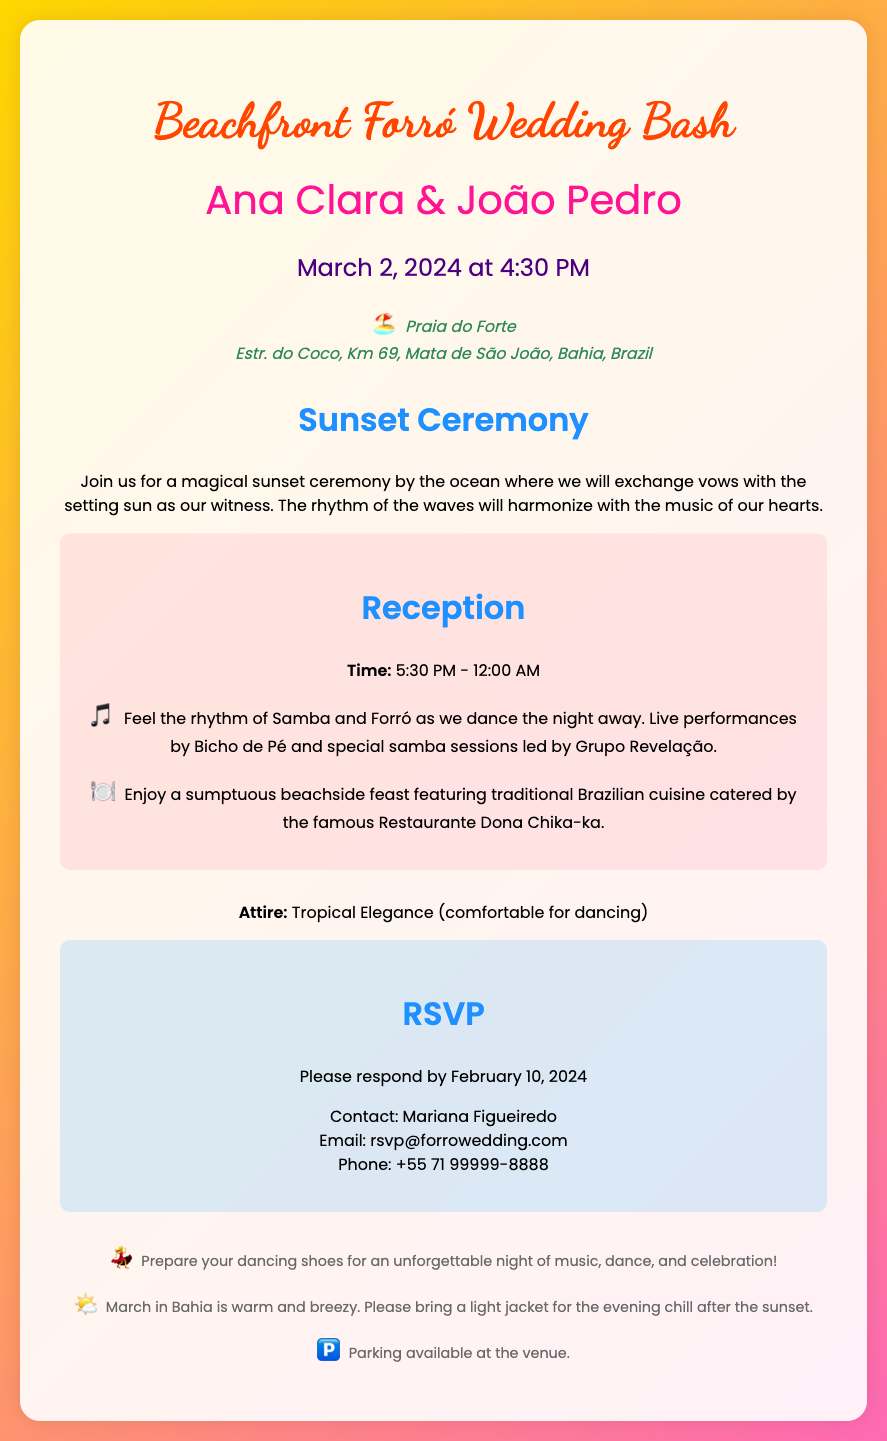What are the names of the couple? The names are highlighted in the document as the couple getting married.
Answer: Ana Clara & João Pedro When is the wedding date? The date is clearly stated in the document under the date-time section.
Answer: March 2, 2024 What time does the ceremony start? The starting time of the ceremony is specified next to the wedding date.
Answer: 4:30 PM Where is the wedding location? The location is detailed in the address section of the invitation.
Answer: Praia do Forte, Estr. do Coco, Km 69, Mata de São João, Bahia, Brazil What kind of music will be featured at the reception? The document mentions the types of music during the reception.
Answer: Samba and Forró How long will the reception last? The duration of the reception is provided in the details section.
Answer: 5:30 PM - 12:00 AM By when should guests RSVP? The RSVP deadline is clearly mentioned in the RSVP section of the document.
Answer: February 10, 2024 What attire is suggested for the guests? The attire recommendation is given in the details section of the invitation.
Answer: Tropical Elegance Who should guests contact for the RSVP? The contact information for the RSVP is provided in the invitation.
Answer: Mariana Figueiredo 